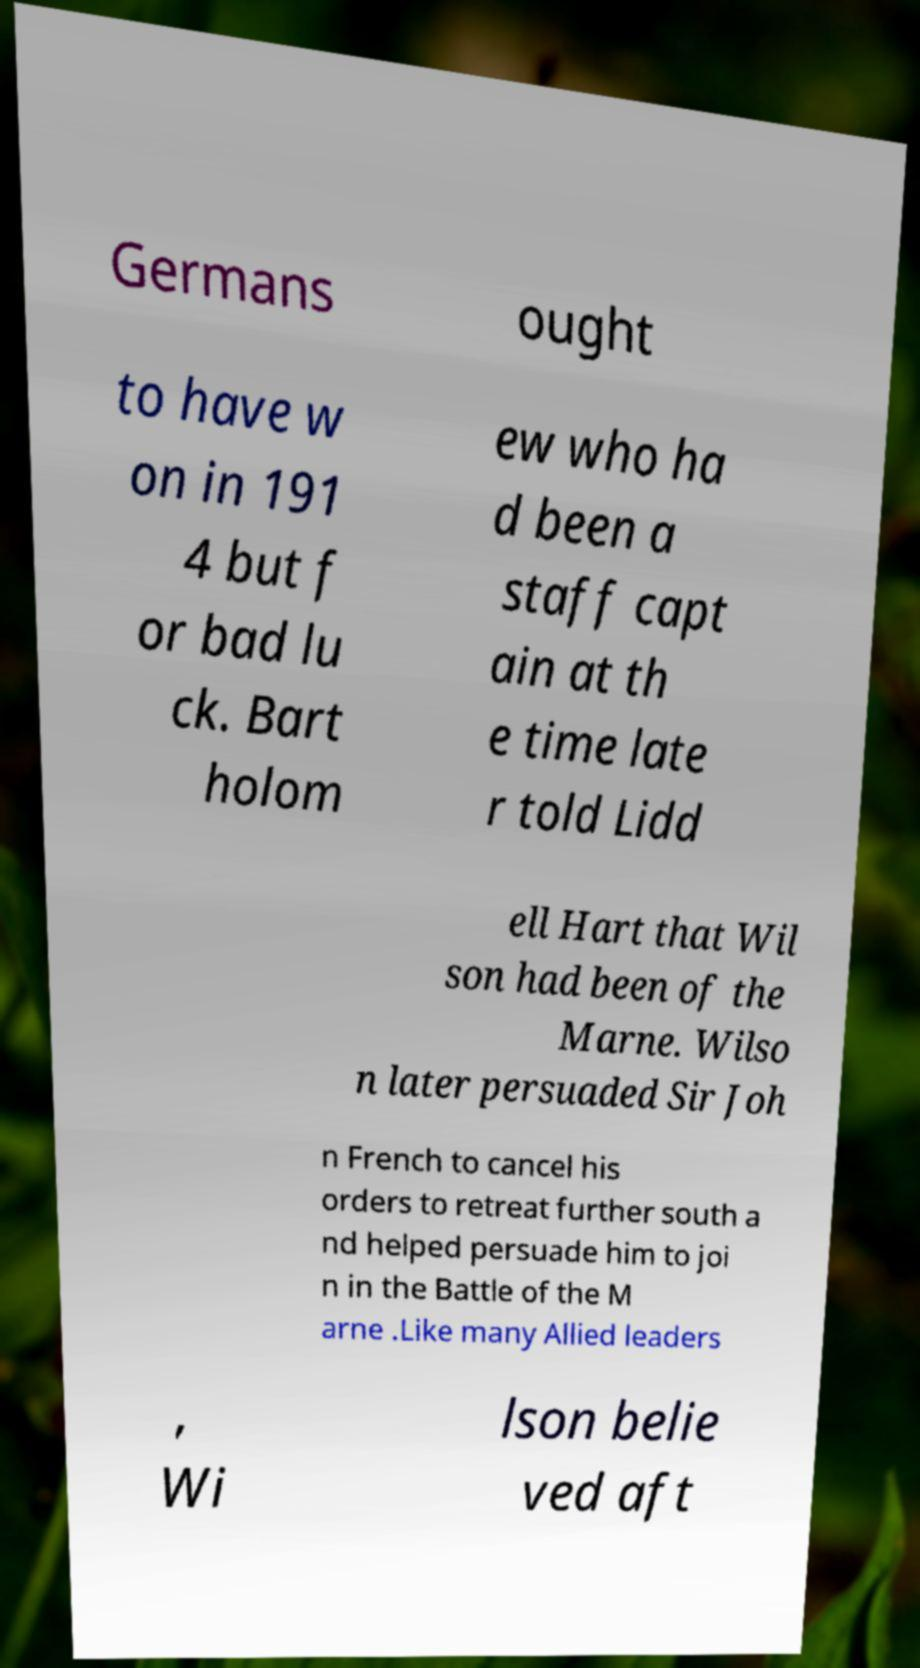Can you read and provide the text displayed in the image?This photo seems to have some interesting text. Can you extract and type it out for me? Germans ought to have w on in 191 4 but f or bad lu ck. Bart holom ew who ha d been a staff capt ain at th e time late r told Lidd ell Hart that Wil son had been of the Marne. Wilso n later persuaded Sir Joh n French to cancel his orders to retreat further south a nd helped persuade him to joi n in the Battle of the M arne .Like many Allied leaders , Wi lson belie ved aft 